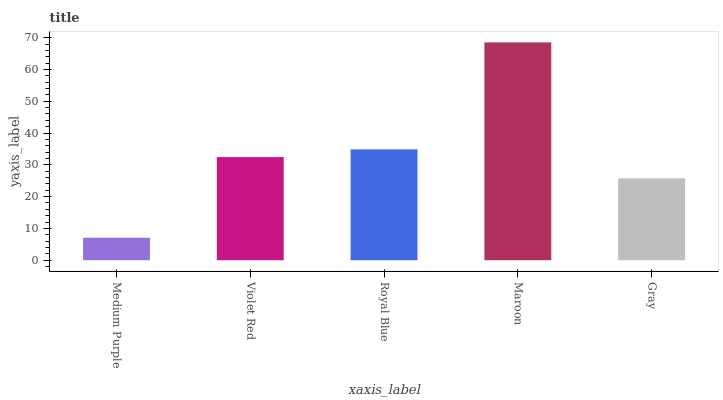Is Medium Purple the minimum?
Answer yes or no. Yes. Is Maroon the maximum?
Answer yes or no. Yes. Is Violet Red the minimum?
Answer yes or no. No. Is Violet Red the maximum?
Answer yes or no. No. Is Violet Red greater than Medium Purple?
Answer yes or no. Yes. Is Medium Purple less than Violet Red?
Answer yes or no. Yes. Is Medium Purple greater than Violet Red?
Answer yes or no. No. Is Violet Red less than Medium Purple?
Answer yes or no. No. Is Violet Red the high median?
Answer yes or no. Yes. Is Violet Red the low median?
Answer yes or no. Yes. Is Maroon the high median?
Answer yes or no. No. Is Medium Purple the low median?
Answer yes or no. No. 